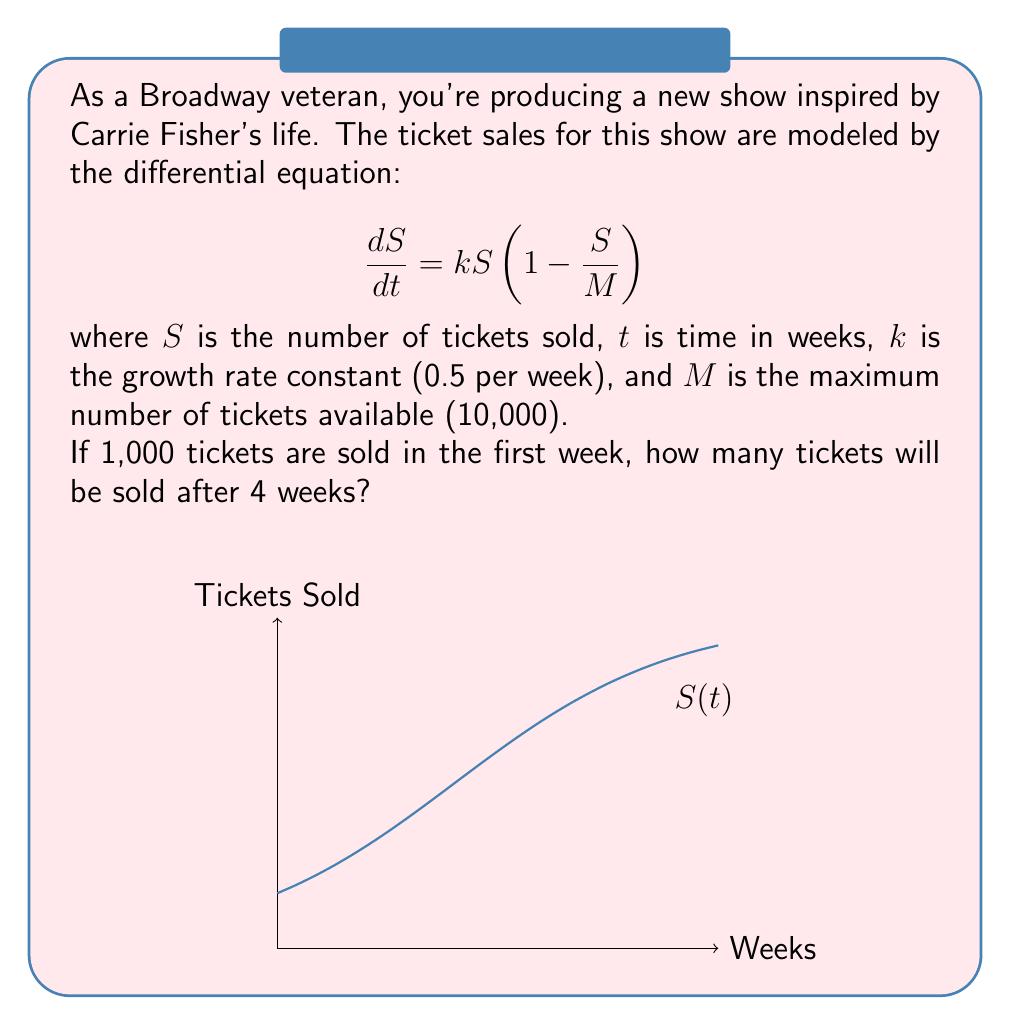Help me with this question. Let's solve this step-by-step:

1) The given differential equation is the logistic growth model. Its solution is:

   $$S(t) = \frac{M}{1 + (\frac{M}{S_0} - 1)e^{-kt}}$$

   where $S_0$ is the initial number of tickets sold.

2) We're given:
   $M = 10,000$
   $k = 0.5$ per week
   $S_0 = 1,000$
   $t = 4$ weeks

3) Let's substitute these values into the equation:

   $$S(4) = \frac{10,000}{1 + (\frac{10,000}{1,000} - 1)e^{-0.5(4)}}$$

4) Simplify:
   $$S(4) = \frac{10,000}{1 + 9e^{-2}}$$

5) Calculate $e^{-2} \approx 0.1353$:
   $$S(4) = \frac{10,000}{1 + 9(0.1353)} \approx \frac{10,000}{2.2177}$$

6) Compute the final result:
   $$S(4) \approx 4,509.63$$

7) Since we can't sell partial tickets, we round down to the nearest whole number.
Answer: 4,509 tickets 